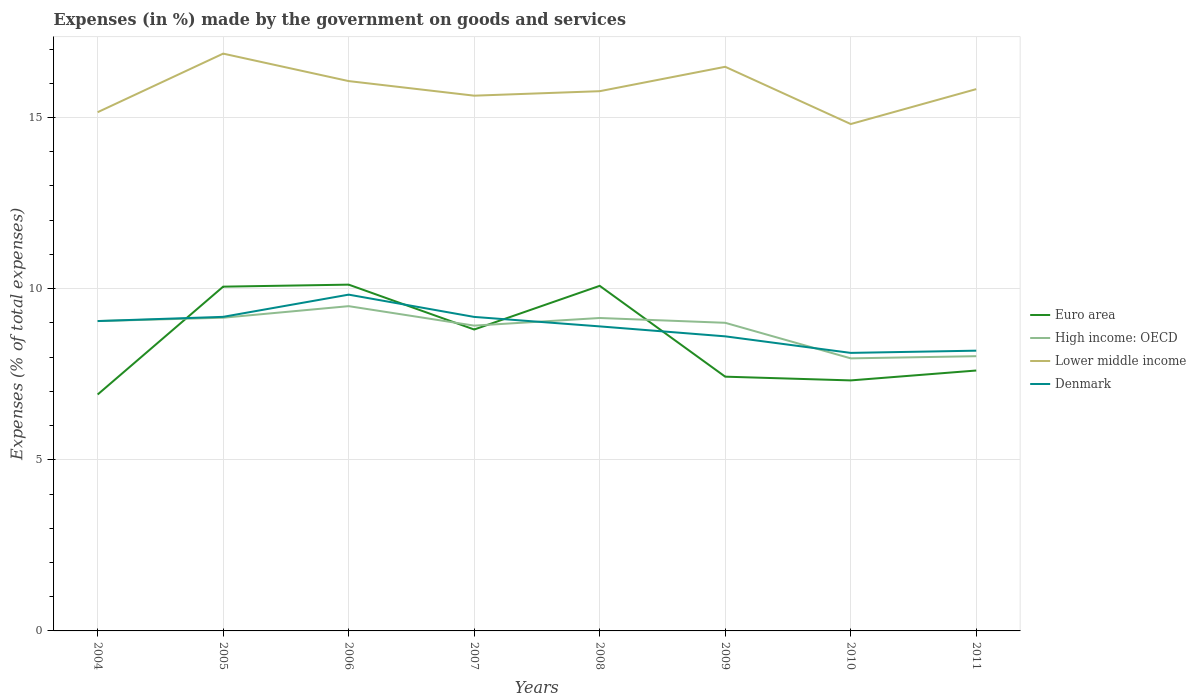Is the number of lines equal to the number of legend labels?
Offer a very short reply. Yes. Across all years, what is the maximum percentage of expenses made by the government on goods and services in High income: OECD?
Give a very brief answer. 7.96. In which year was the percentage of expenses made by the government on goods and services in Denmark maximum?
Ensure brevity in your answer.  2010. What is the total percentage of expenses made by the government on goods and services in Lower middle income in the graph?
Keep it short and to the point. -0.67. What is the difference between the highest and the second highest percentage of expenses made by the government on goods and services in High income: OECD?
Your response must be concise. 1.53. How many lines are there?
Offer a terse response. 4. How many years are there in the graph?
Provide a succinct answer. 8. What is the difference between two consecutive major ticks on the Y-axis?
Ensure brevity in your answer.  5. Are the values on the major ticks of Y-axis written in scientific E-notation?
Keep it short and to the point. No. Does the graph contain any zero values?
Provide a succinct answer. No. How many legend labels are there?
Make the answer very short. 4. What is the title of the graph?
Give a very brief answer. Expenses (in %) made by the government on goods and services. What is the label or title of the Y-axis?
Provide a short and direct response. Expenses (% of total expenses). What is the Expenses (% of total expenses) in Euro area in 2004?
Your response must be concise. 6.91. What is the Expenses (% of total expenses) in High income: OECD in 2004?
Ensure brevity in your answer.  9.05. What is the Expenses (% of total expenses) in Lower middle income in 2004?
Provide a short and direct response. 15.16. What is the Expenses (% of total expenses) of Denmark in 2004?
Provide a short and direct response. 9.05. What is the Expenses (% of total expenses) in Euro area in 2005?
Keep it short and to the point. 10.06. What is the Expenses (% of total expenses) of High income: OECD in 2005?
Make the answer very short. 9.15. What is the Expenses (% of total expenses) in Lower middle income in 2005?
Make the answer very short. 16.87. What is the Expenses (% of total expenses) of Denmark in 2005?
Make the answer very short. 9.18. What is the Expenses (% of total expenses) in Euro area in 2006?
Keep it short and to the point. 10.12. What is the Expenses (% of total expenses) in High income: OECD in 2006?
Provide a succinct answer. 9.49. What is the Expenses (% of total expenses) in Lower middle income in 2006?
Ensure brevity in your answer.  16.07. What is the Expenses (% of total expenses) in Denmark in 2006?
Your answer should be compact. 9.83. What is the Expenses (% of total expenses) in Euro area in 2007?
Give a very brief answer. 8.81. What is the Expenses (% of total expenses) in High income: OECD in 2007?
Keep it short and to the point. 8.92. What is the Expenses (% of total expenses) of Lower middle income in 2007?
Your answer should be very brief. 15.64. What is the Expenses (% of total expenses) in Denmark in 2007?
Offer a very short reply. 9.17. What is the Expenses (% of total expenses) in Euro area in 2008?
Your response must be concise. 10.08. What is the Expenses (% of total expenses) of High income: OECD in 2008?
Offer a terse response. 9.14. What is the Expenses (% of total expenses) in Lower middle income in 2008?
Keep it short and to the point. 15.77. What is the Expenses (% of total expenses) in Denmark in 2008?
Keep it short and to the point. 8.9. What is the Expenses (% of total expenses) of Euro area in 2009?
Offer a terse response. 7.43. What is the Expenses (% of total expenses) in High income: OECD in 2009?
Offer a terse response. 9. What is the Expenses (% of total expenses) in Lower middle income in 2009?
Your response must be concise. 16.48. What is the Expenses (% of total expenses) in Denmark in 2009?
Offer a very short reply. 8.61. What is the Expenses (% of total expenses) of Euro area in 2010?
Provide a short and direct response. 7.32. What is the Expenses (% of total expenses) of High income: OECD in 2010?
Your response must be concise. 7.96. What is the Expenses (% of total expenses) in Lower middle income in 2010?
Offer a very short reply. 14.81. What is the Expenses (% of total expenses) in Denmark in 2010?
Provide a succinct answer. 8.12. What is the Expenses (% of total expenses) in Euro area in 2011?
Provide a short and direct response. 7.61. What is the Expenses (% of total expenses) in High income: OECD in 2011?
Keep it short and to the point. 8.03. What is the Expenses (% of total expenses) of Lower middle income in 2011?
Give a very brief answer. 15.83. What is the Expenses (% of total expenses) in Denmark in 2011?
Provide a succinct answer. 8.19. Across all years, what is the maximum Expenses (% of total expenses) of Euro area?
Ensure brevity in your answer.  10.12. Across all years, what is the maximum Expenses (% of total expenses) in High income: OECD?
Your answer should be compact. 9.49. Across all years, what is the maximum Expenses (% of total expenses) of Lower middle income?
Your answer should be compact. 16.87. Across all years, what is the maximum Expenses (% of total expenses) in Denmark?
Your answer should be compact. 9.83. Across all years, what is the minimum Expenses (% of total expenses) in Euro area?
Ensure brevity in your answer.  6.91. Across all years, what is the minimum Expenses (% of total expenses) in High income: OECD?
Make the answer very short. 7.96. Across all years, what is the minimum Expenses (% of total expenses) of Lower middle income?
Your answer should be compact. 14.81. Across all years, what is the minimum Expenses (% of total expenses) in Denmark?
Keep it short and to the point. 8.12. What is the total Expenses (% of total expenses) of Euro area in the graph?
Keep it short and to the point. 68.33. What is the total Expenses (% of total expenses) in High income: OECD in the graph?
Keep it short and to the point. 70.75. What is the total Expenses (% of total expenses) of Lower middle income in the graph?
Provide a succinct answer. 126.62. What is the total Expenses (% of total expenses) of Denmark in the graph?
Your response must be concise. 71.05. What is the difference between the Expenses (% of total expenses) of Euro area in 2004 and that in 2005?
Provide a succinct answer. -3.15. What is the difference between the Expenses (% of total expenses) of High income: OECD in 2004 and that in 2005?
Your answer should be very brief. -0.1. What is the difference between the Expenses (% of total expenses) in Lower middle income in 2004 and that in 2005?
Ensure brevity in your answer.  -1.71. What is the difference between the Expenses (% of total expenses) of Denmark in 2004 and that in 2005?
Keep it short and to the point. -0.12. What is the difference between the Expenses (% of total expenses) of Euro area in 2004 and that in 2006?
Make the answer very short. -3.21. What is the difference between the Expenses (% of total expenses) of High income: OECD in 2004 and that in 2006?
Provide a succinct answer. -0.44. What is the difference between the Expenses (% of total expenses) of Lower middle income in 2004 and that in 2006?
Your answer should be compact. -0.91. What is the difference between the Expenses (% of total expenses) in Denmark in 2004 and that in 2006?
Your answer should be compact. -0.77. What is the difference between the Expenses (% of total expenses) of Euro area in 2004 and that in 2007?
Your answer should be compact. -1.9. What is the difference between the Expenses (% of total expenses) in High income: OECD in 2004 and that in 2007?
Offer a terse response. 0.13. What is the difference between the Expenses (% of total expenses) of Lower middle income in 2004 and that in 2007?
Provide a succinct answer. -0.48. What is the difference between the Expenses (% of total expenses) of Denmark in 2004 and that in 2007?
Give a very brief answer. -0.12. What is the difference between the Expenses (% of total expenses) of Euro area in 2004 and that in 2008?
Give a very brief answer. -3.18. What is the difference between the Expenses (% of total expenses) of High income: OECD in 2004 and that in 2008?
Keep it short and to the point. -0.09. What is the difference between the Expenses (% of total expenses) of Lower middle income in 2004 and that in 2008?
Offer a terse response. -0.61. What is the difference between the Expenses (% of total expenses) of Denmark in 2004 and that in 2008?
Provide a short and direct response. 0.16. What is the difference between the Expenses (% of total expenses) in Euro area in 2004 and that in 2009?
Offer a terse response. -0.52. What is the difference between the Expenses (% of total expenses) of High income: OECD in 2004 and that in 2009?
Make the answer very short. 0.05. What is the difference between the Expenses (% of total expenses) in Lower middle income in 2004 and that in 2009?
Offer a terse response. -1.33. What is the difference between the Expenses (% of total expenses) of Denmark in 2004 and that in 2009?
Your response must be concise. 0.45. What is the difference between the Expenses (% of total expenses) of Euro area in 2004 and that in 2010?
Offer a terse response. -0.41. What is the difference between the Expenses (% of total expenses) in High income: OECD in 2004 and that in 2010?
Keep it short and to the point. 1.09. What is the difference between the Expenses (% of total expenses) in Lower middle income in 2004 and that in 2010?
Your answer should be compact. 0.35. What is the difference between the Expenses (% of total expenses) in Denmark in 2004 and that in 2010?
Provide a succinct answer. 0.93. What is the difference between the Expenses (% of total expenses) of Euro area in 2004 and that in 2011?
Your answer should be compact. -0.7. What is the difference between the Expenses (% of total expenses) of High income: OECD in 2004 and that in 2011?
Make the answer very short. 1.03. What is the difference between the Expenses (% of total expenses) of Lower middle income in 2004 and that in 2011?
Offer a terse response. -0.67. What is the difference between the Expenses (% of total expenses) in Denmark in 2004 and that in 2011?
Ensure brevity in your answer.  0.87. What is the difference between the Expenses (% of total expenses) of Euro area in 2005 and that in 2006?
Keep it short and to the point. -0.06. What is the difference between the Expenses (% of total expenses) of High income: OECD in 2005 and that in 2006?
Your answer should be compact. -0.34. What is the difference between the Expenses (% of total expenses) of Lower middle income in 2005 and that in 2006?
Your answer should be very brief. 0.8. What is the difference between the Expenses (% of total expenses) of Denmark in 2005 and that in 2006?
Offer a very short reply. -0.65. What is the difference between the Expenses (% of total expenses) in Euro area in 2005 and that in 2007?
Your answer should be compact. 1.25. What is the difference between the Expenses (% of total expenses) of High income: OECD in 2005 and that in 2007?
Give a very brief answer. 0.23. What is the difference between the Expenses (% of total expenses) of Lower middle income in 2005 and that in 2007?
Keep it short and to the point. 1.23. What is the difference between the Expenses (% of total expenses) in Denmark in 2005 and that in 2007?
Keep it short and to the point. 0. What is the difference between the Expenses (% of total expenses) of Euro area in 2005 and that in 2008?
Make the answer very short. -0.02. What is the difference between the Expenses (% of total expenses) in High income: OECD in 2005 and that in 2008?
Provide a succinct answer. 0.01. What is the difference between the Expenses (% of total expenses) of Lower middle income in 2005 and that in 2008?
Make the answer very short. 1.1. What is the difference between the Expenses (% of total expenses) of Denmark in 2005 and that in 2008?
Offer a very short reply. 0.28. What is the difference between the Expenses (% of total expenses) in Euro area in 2005 and that in 2009?
Offer a very short reply. 2.63. What is the difference between the Expenses (% of total expenses) in High income: OECD in 2005 and that in 2009?
Your answer should be compact. 0.15. What is the difference between the Expenses (% of total expenses) in Lower middle income in 2005 and that in 2009?
Your response must be concise. 0.39. What is the difference between the Expenses (% of total expenses) in Denmark in 2005 and that in 2009?
Your response must be concise. 0.57. What is the difference between the Expenses (% of total expenses) of Euro area in 2005 and that in 2010?
Your response must be concise. 2.74. What is the difference between the Expenses (% of total expenses) of High income: OECD in 2005 and that in 2010?
Your answer should be very brief. 1.19. What is the difference between the Expenses (% of total expenses) of Lower middle income in 2005 and that in 2010?
Provide a short and direct response. 2.06. What is the difference between the Expenses (% of total expenses) in Denmark in 2005 and that in 2010?
Ensure brevity in your answer.  1.05. What is the difference between the Expenses (% of total expenses) of Euro area in 2005 and that in 2011?
Your response must be concise. 2.45. What is the difference between the Expenses (% of total expenses) of High income: OECD in 2005 and that in 2011?
Provide a short and direct response. 1.12. What is the difference between the Expenses (% of total expenses) in Lower middle income in 2005 and that in 2011?
Offer a very short reply. 1.04. What is the difference between the Expenses (% of total expenses) of Denmark in 2005 and that in 2011?
Provide a succinct answer. 0.99. What is the difference between the Expenses (% of total expenses) in Euro area in 2006 and that in 2007?
Your answer should be compact. 1.31. What is the difference between the Expenses (% of total expenses) in High income: OECD in 2006 and that in 2007?
Your answer should be compact. 0.57. What is the difference between the Expenses (% of total expenses) of Lower middle income in 2006 and that in 2007?
Keep it short and to the point. 0.43. What is the difference between the Expenses (% of total expenses) in Denmark in 2006 and that in 2007?
Ensure brevity in your answer.  0.65. What is the difference between the Expenses (% of total expenses) of Euro area in 2006 and that in 2008?
Give a very brief answer. 0.04. What is the difference between the Expenses (% of total expenses) in High income: OECD in 2006 and that in 2008?
Offer a terse response. 0.35. What is the difference between the Expenses (% of total expenses) of Lower middle income in 2006 and that in 2008?
Offer a terse response. 0.29. What is the difference between the Expenses (% of total expenses) in Denmark in 2006 and that in 2008?
Give a very brief answer. 0.93. What is the difference between the Expenses (% of total expenses) in Euro area in 2006 and that in 2009?
Keep it short and to the point. 2.69. What is the difference between the Expenses (% of total expenses) in High income: OECD in 2006 and that in 2009?
Offer a terse response. 0.49. What is the difference between the Expenses (% of total expenses) of Lower middle income in 2006 and that in 2009?
Your answer should be very brief. -0.42. What is the difference between the Expenses (% of total expenses) in Denmark in 2006 and that in 2009?
Provide a succinct answer. 1.22. What is the difference between the Expenses (% of total expenses) in Euro area in 2006 and that in 2010?
Ensure brevity in your answer.  2.8. What is the difference between the Expenses (% of total expenses) in High income: OECD in 2006 and that in 2010?
Offer a very short reply. 1.53. What is the difference between the Expenses (% of total expenses) in Lower middle income in 2006 and that in 2010?
Offer a terse response. 1.25. What is the difference between the Expenses (% of total expenses) in Denmark in 2006 and that in 2010?
Give a very brief answer. 1.7. What is the difference between the Expenses (% of total expenses) of Euro area in 2006 and that in 2011?
Your answer should be very brief. 2.51. What is the difference between the Expenses (% of total expenses) in High income: OECD in 2006 and that in 2011?
Offer a very short reply. 1.46. What is the difference between the Expenses (% of total expenses) in Lower middle income in 2006 and that in 2011?
Keep it short and to the point. 0.23. What is the difference between the Expenses (% of total expenses) of Denmark in 2006 and that in 2011?
Provide a succinct answer. 1.64. What is the difference between the Expenses (% of total expenses) in Euro area in 2007 and that in 2008?
Offer a very short reply. -1.28. What is the difference between the Expenses (% of total expenses) in High income: OECD in 2007 and that in 2008?
Provide a succinct answer. -0.22. What is the difference between the Expenses (% of total expenses) of Lower middle income in 2007 and that in 2008?
Your answer should be compact. -0.13. What is the difference between the Expenses (% of total expenses) of Denmark in 2007 and that in 2008?
Provide a succinct answer. 0.28. What is the difference between the Expenses (% of total expenses) of Euro area in 2007 and that in 2009?
Offer a very short reply. 1.38. What is the difference between the Expenses (% of total expenses) of High income: OECD in 2007 and that in 2009?
Your answer should be very brief. -0.08. What is the difference between the Expenses (% of total expenses) in Lower middle income in 2007 and that in 2009?
Your answer should be very brief. -0.84. What is the difference between the Expenses (% of total expenses) in Denmark in 2007 and that in 2009?
Provide a succinct answer. 0.57. What is the difference between the Expenses (% of total expenses) in Euro area in 2007 and that in 2010?
Your answer should be very brief. 1.49. What is the difference between the Expenses (% of total expenses) in High income: OECD in 2007 and that in 2010?
Provide a succinct answer. 0.96. What is the difference between the Expenses (% of total expenses) of Lower middle income in 2007 and that in 2010?
Keep it short and to the point. 0.83. What is the difference between the Expenses (% of total expenses) of Denmark in 2007 and that in 2010?
Your response must be concise. 1.05. What is the difference between the Expenses (% of total expenses) of Euro area in 2007 and that in 2011?
Offer a very short reply. 1.2. What is the difference between the Expenses (% of total expenses) of High income: OECD in 2007 and that in 2011?
Give a very brief answer. 0.89. What is the difference between the Expenses (% of total expenses) in Lower middle income in 2007 and that in 2011?
Your answer should be very brief. -0.19. What is the difference between the Expenses (% of total expenses) in Denmark in 2007 and that in 2011?
Offer a terse response. 0.99. What is the difference between the Expenses (% of total expenses) in Euro area in 2008 and that in 2009?
Offer a terse response. 2.65. What is the difference between the Expenses (% of total expenses) in High income: OECD in 2008 and that in 2009?
Your answer should be very brief. 0.14. What is the difference between the Expenses (% of total expenses) of Lower middle income in 2008 and that in 2009?
Your answer should be compact. -0.71. What is the difference between the Expenses (% of total expenses) of Denmark in 2008 and that in 2009?
Provide a short and direct response. 0.29. What is the difference between the Expenses (% of total expenses) in Euro area in 2008 and that in 2010?
Your answer should be compact. 2.76. What is the difference between the Expenses (% of total expenses) in High income: OECD in 2008 and that in 2010?
Ensure brevity in your answer.  1.18. What is the difference between the Expenses (% of total expenses) in Lower middle income in 2008 and that in 2010?
Make the answer very short. 0.96. What is the difference between the Expenses (% of total expenses) of Denmark in 2008 and that in 2010?
Give a very brief answer. 0.77. What is the difference between the Expenses (% of total expenses) in Euro area in 2008 and that in 2011?
Make the answer very short. 2.47. What is the difference between the Expenses (% of total expenses) of High income: OECD in 2008 and that in 2011?
Give a very brief answer. 1.12. What is the difference between the Expenses (% of total expenses) of Lower middle income in 2008 and that in 2011?
Keep it short and to the point. -0.06. What is the difference between the Expenses (% of total expenses) of Denmark in 2008 and that in 2011?
Provide a short and direct response. 0.71. What is the difference between the Expenses (% of total expenses) of Euro area in 2009 and that in 2010?
Your answer should be very brief. 0.11. What is the difference between the Expenses (% of total expenses) of High income: OECD in 2009 and that in 2010?
Offer a very short reply. 1.04. What is the difference between the Expenses (% of total expenses) of Lower middle income in 2009 and that in 2010?
Offer a very short reply. 1.67. What is the difference between the Expenses (% of total expenses) of Denmark in 2009 and that in 2010?
Make the answer very short. 0.48. What is the difference between the Expenses (% of total expenses) in Euro area in 2009 and that in 2011?
Offer a very short reply. -0.18. What is the difference between the Expenses (% of total expenses) in High income: OECD in 2009 and that in 2011?
Your answer should be very brief. 0.98. What is the difference between the Expenses (% of total expenses) in Lower middle income in 2009 and that in 2011?
Offer a terse response. 0.65. What is the difference between the Expenses (% of total expenses) of Denmark in 2009 and that in 2011?
Your response must be concise. 0.42. What is the difference between the Expenses (% of total expenses) in Euro area in 2010 and that in 2011?
Make the answer very short. -0.29. What is the difference between the Expenses (% of total expenses) in High income: OECD in 2010 and that in 2011?
Keep it short and to the point. -0.06. What is the difference between the Expenses (% of total expenses) of Lower middle income in 2010 and that in 2011?
Offer a very short reply. -1.02. What is the difference between the Expenses (% of total expenses) of Denmark in 2010 and that in 2011?
Offer a very short reply. -0.06. What is the difference between the Expenses (% of total expenses) of Euro area in 2004 and the Expenses (% of total expenses) of High income: OECD in 2005?
Give a very brief answer. -2.24. What is the difference between the Expenses (% of total expenses) of Euro area in 2004 and the Expenses (% of total expenses) of Lower middle income in 2005?
Offer a very short reply. -9.96. What is the difference between the Expenses (% of total expenses) of Euro area in 2004 and the Expenses (% of total expenses) of Denmark in 2005?
Offer a terse response. -2.27. What is the difference between the Expenses (% of total expenses) in High income: OECD in 2004 and the Expenses (% of total expenses) in Lower middle income in 2005?
Your response must be concise. -7.81. What is the difference between the Expenses (% of total expenses) of High income: OECD in 2004 and the Expenses (% of total expenses) of Denmark in 2005?
Provide a succinct answer. -0.12. What is the difference between the Expenses (% of total expenses) of Lower middle income in 2004 and the Expenses (% of total expenses) of Denmark in 2005?
Provide a short and direct response. 5.98. What is the difference between the Expenses (% of total expenses) of Euro area in 2004 and the Expenses (% of total expenses) of High income: OECD in 2006?
Provide a succinct answer. -2.58. What is the difference between the Expenses (% of total expenses) of Euro area in 2004 and the Expenses (% of total expenses) of Lower middle income in 2006?
Give a very brief answer. -9.16. What is the difference between the Expenses (% of total expenses) in Euro area in 2004 and the Expenses (% of total expenses) in Denmark in 2006?
Your answer should be compact. -2.92. What is the difference between the Expenses (% of total expenses) of High income: OECD in 2004 and the Expenses (% of total expenses) of Lower middle income in 2006?
Ensure brevity in your answer.  -7.01. What is the difference between the Expenses (% of total expenses) of High income: OECD in 2004 and the Expenses (% of total expenses) of Denmark in 2006?
Provide a short and direct response. -0.77. What is the difference between the Expenses (% of total expenses) in Lower middle income in 2004 and the Expenses (% of total expenses) in Denmark in 2006?
Provide a succinct answer. 5.33. What is the difference between the Expenses (% of total expenses) of Euro area in 2004 and the Expenses (% of total expenses) of High income: OECD in 2007?
Your answer should be compact. -2.01. What is the difference between the Expenses (% of total expenses) in Euro area in 2004 and the Expenses (% of total expenses) in Lower middle income in 2007?
Keep it short and to the point. -8.73. What is the difference between the Expenses (% of total expenses) of Euro area in 2004 and the Expenses (% of total expenses) of Denmark in 2007?
Keep it short and to the point. -2.27. What is the difference between the Expenses (% of total expenses) in High income: OECD in 2004 and the Expenses (% of total expenses) in Lower middle income in 2007?
Offer a very short reply. -6.59. What is the difference between the Expenses (% of total expenses) of High income: OECD in 2004 and the Expenses (% of total expenses) of Denmark in 2007?
Your answer should be very brief. -0.12. What is the difference between the Expenses (% of total expenses) of Lower middle income in 2004 and the Expenses (% of total expenses) of Denmark in 2007?
Your answer should be compact. 5.98. What is the difference between the Expenses (% of total expenses) of Euro area in 2004 and the Expenses (% of total expenses) of High income: OECD in 2008?
Your answer should be compact. -2.24. What is the difference between the Expenses (% of total expenses) in Euro area in 2004 and the Expenses (% of total expenses) in Lower middle income in 2008?
Give a very brief answer. -8.86. What is the difference between the Expenses (% of total expenses) of Euro area in 2004 and the Expenses (% of total expenses) of Denmark in 2008?
Offer a very short reply. -1.99. What is the difference between the Expenses (% of total expenses) in High income: OECD in 2004 and the Expenses (% of total expenses) in Lower middle income in 2008?
Your response must be concise. -6.72. What is the difference between the Expenses (% of total expenses) of High income: OECD in 2004 and the Expenses (% of total expenses) of Denmark in 2008?
Offer a terse response. 0.16. What is the difference between the Expenses (% of total expenses) in Lower middle income in 2004 and the Expenses (% of total expenses) in Denmark in 2008?
Make the answer very short. 6.26. What is the difference between the Expenses (% of total expenses) in Euro area in 2004 and the Expenses (% of total expenses) in High income: OECD in 2009?
Your answer should be compact. -2.1. What is the difference between the Expenses (% of total expenses) of Euro area in 2004 and the Expenses (% of total expenses) of Lower middle income in 2009?
Offer a terse response. -9.58. What is the difference between the Expenses (% of total expenses) of Euro area in 2004 and the Expenses (% of total expenses) of Denmark in 2009?
Provide a succinct answer. -1.7. What is the difference between the Expenses (% of total expenses) in High income: OECD in 2004 and the Expenses (% of total expenses) in Lower middle income in 2009?
Your response must be concise. -7.43. What is the difference between the Expenses (% of total expenses) in High income: OECD in 2004 and the Expenses (% of total expenses) in Denmark in 2009?
Make the answer very short. 0.45. What is the difference between the Expenses (% of total expenses) in Lower middle income in 2004 and the Expenses (% of total expenses) in Denmark in 2009?
Make the answer very short. 6.55. What is the difference between the Expenses (% of total expenses) in Euro area in 2004 and the Expenses (% of total expenses) in High income: OECD in 2010?
Offer a very short reply. -1.06. What is the difference between the Expenses (% of total expenses) in Euro area in 2004 and the Expenses (% of total expenses) in Lower middle income in 2010?
Provide a succinct answer. -7.9. What is the difference between the Expenses (% of total expenses) in Euro area in 2004 and the Expenses (% of total expenses) in Denmark in 2010?
Provide a short and direct response. -1.22. What is the difference between the Expenses (% of total expenses) of High income: OECD in 2004 and the Expenses (% of total expenses) of Lower middle income in 2010?
Keep it short and to the point. -5.76. What is the difference between the Expenses (% of total expenses) of High income: OECD in 2004 and the Expenses (% of total expenses) of Denmark in 2010?
Provide a short and direct response. 0.93. What is the difference between the Expenses (% of total expenses) in Lower middle income in 2004 and the Expenses (% of total expenses) in Denmark in 2010?
Provide a short and direct response. 7.03. What is the difference between the Expenses (% of total expenses) of Euro area in 2004 and the Expenses (% of total expenses) of High income: OECD in 2011?
Give a very brief answer. -1.12. What is the difference between the Expenses (% of total expenses) in Euro area in 2004 and the Expenses (% of total expenses) in Lower middle income in 2011?
Keep it short and to the point. -8.92. What is the difference between the Expenses (% of total expenses) of Euro area in 2004 and the Expenses (% of total expenses) of Denmark in 2011?
Your answer should be very brief. -1.28. What is the difference between the Expenses (% of total expenses) of High income: OECD in 2004 and the Expenses (% of total expenses) of Lower middle income in 2011?
Your answer should be compact. -6.78. What is the difference between the Expenses (% of total expenses) in High income: OECD in 2004 and the Expenses (% of total expenses) in Denmark in 2011?
Make the answer very short. 0.87. What is the difference between the Expenses (% of total expenses) of Lower middle income in 2004 and the Expenses (% of total expenses) of Denmark in 2011?
Give a very brief answer. 6.97. What is the difference between the Expenses (% of total expenses) of Euro area in 2005 and the Expenses (% of total expenses) of High income: OECD in 2006?
Keep it short and to the point. 0.57. What is the difference between the Expenses (% of total expenses) of Euro area in 2005 and the Expenses (% of total expenses) of Lower middle income in 2006?
Ensure brevity in your answer.  -6.01. What is the difference between the Expenses (% of total expenses) of Euro area in 2005 and the Expenses (% of total expenses) of Denmark in 2006?
Provide a short and direct response. 0.23. What is the difference between the Expenses (% of total expenses) in High income: OECD in 2005 and the Expenses (% of total expenses) in Lower middle income in 2006?
Make the answer very short. -6.91. What is the difference between the Expenses (% of total expenses) of High income: OECD in 2005 and the Expenses (% of total expenses) of Denmark in 2006?
Offer a very short reply. -0.67. What is the difference between the Expenses (% of total expenses) of Lower middle income in 2005 and the Expenses (% of total expenses) of Denmark in 2006?
Give a very brief answer. 7.04. What is the difference between the Expenses (% of total expenses) of Euro area in 2005 and the Expenses (% of total expenses) of High income: OECD in 2007?
Make the answer very short. 1.14. What is the difference between the Expenses (% of total expenses) in Euro area in 2005 and the Expenses (% of total expenses) in Lower middle income in 2007?
Give a very brief answer. -5.58. What is the difference between the Expenses (% of total expenses) in Euro area in 2005 and the Expenses (% of total expenses) in Denmark in 2007?
Your response must be concise. 0.88. What is the difference between the Expenses (% of total expenses) in High income: OECD in 2005 and the Expenses (% of total expenses) in Lower middle income in 2007?
Your answer should be very brief. -6.49. What is the difference between the Expenses (% of total expenses) in High income: OECD in 2005 and the Expenses (% of total expenses) in Denmark in 2007?
Keep it short and to the point. -0.02. What is the difference between the Expenses (% of total expenses) of Lower middle income in 2005 and the Expenses (% of total expenses) of Denmark in 2007?
Ensure brevity in your answer.  7.69. What is the difference between the Expenses (% of total expenses) in Euro area in 2005 and the Expenses (% of total expenses) in High income: OECD in 2008?
Ensure brevity in your answer.  0.92. What is the difference between the Expenses (% of total expenses) of Euro area in 2005 and the Expenses (% of total expenses) of Lower middle income in 2008?
Ensure brevity in your answer.  -5.71. What is the difference between the Expenses (% of total expenses) in Euro area in 2005 and the Expenses (% of total expenses) in Denmark in 2008?
Give a very brief answer. 1.16. What is the difference between the Expenses (% of total expenses) in High income: OECD in 2005 and the Expenses (% of total expenses) in Lower middle income in 2008?
Ensure brevity in your answer.  -6.62. What is the difference between the Expenses (% of total expenses) in High income: OECD in 2005 and the Expenses (% of total expenses) in Denmark in 2008?
Give a very brief answer. 0.25. What is the difference between the Expenses (% of total expenses) in Lower middle income in 2005 and the Expenses (% of total expenses) in Denmark in 2008?
Make the answer very short. 7.97. What is the difference between the Expenses (% of total expenses) in Euro area in 2005 and the Expenses (% of total expenses) in High income: OECD in 2009?
Give a very brief answer. 1.06. What is the difference between the Expenses (% of total expenses) in Euro area in 2005 and the Expenses (% of total expenses) in Lower middle income in 2009?
Give a very brief answer. -6.42. What is the difference between the Expenses (% of total expenses) of Euro area in 2005 and the Expenses (% of total expenses) of Denmark in 2009?
Your answer should be compact. 1.45. What is the difference between the Expenses (% of total expenses) of High income: OECD in 2005 and the Expenses (% of total expenses) of Lower middle income in 2009?
Offer a very short reply. -7.33. What is the difference between the Expenses (% of total expenses) of High income: OECD in 2005 and the Expenses (% of total expenses) of Denmark in 2009?
Your response must be concise. 0.54. What is the difference between the Expenses (% of total expenses) in Lower middle income in 2005 and the Expenses (% of total expenses) in Denmark in 2009?
Ensure brevity in your answer.  8.26. What is the difference between the Expenses (% of total expenses) of Euro area in 2005 and the Expenses (% of total expenses) of High income: OECD in 2010?
Ensure brevity in your answer.  2.09. What is the difference between the Expenses (% of total expenses) of Euro area in 2005 and the Expenses (% of total expenses) of Lower middle income in 2010?
Offer a terse response. -4.75. What is the difference between the Expenses (% of total expenses) of Euro area in 2005 and the Expenses (% of total expenses) of Denmark in 2010?
Offer a very short reply. 1.94. What is the difference between the Expenses (% of total expenses) of High income: OECD in 2005 and the Expenses (% of total expenses) of Lower middle income in 2010?
Make the answer very short. -5.66. What is the difference between the Expenses (% of total expenses) of High income: OECD in 2005 and the Expenses (% of total expenses) of Denmark in 2010?
Keep it short and to the point. 1.03. What is the difference between the Expenses (% of total expenses) of Lower middle income in 2005 and the Expenses (% of total expenses) of Denmark in 2010?
Your response must be concise. 8.74. What is the difference between the Expenses (% of total expenses) in Euro area in 2005 and the Expenses (% of total expenses) in High income: OECD in 2011?
Ensure brevity in your answer.  2.03. What is the difference between the Expenses (% of total expenses) in Euro area in 2005 and the Expenses (% of total expenses) in Lower middle income in 2011?
Offer a terse response. -5.77. What is the difference between the Expenses (% of total expenses) of Euro area in 2005 and the Expenses (% of total expenses) of Denmark in 2011?
Make the answer very short. 1.87. What is the difference between the Expenses (% of total expenses) of High income: OECD in 2005 and the Expenses (% of total expenses) of Lower middle income in 2011?
Your response must be concise. -6.68. What is the difference between the Expenses (% of total expenses) in High income: OECD in 2005 and the Expenses (% of total expenses) in Denmark in 2011?
Give a very brief answer. 0.96. What is the difference between the Expenses (% of total expenses) of Lower middle income in 2005 and the Expenses (% of total expenses) of Denmark in 2011?
Offer a very short reply. 8.68. What is the difference between the Expenses (% of total expenses) of Euro area in 2006 and the Expenses (% of total expenses) of High income: OECD in 2007?
Make the answer very short. 1.2. What is the difference between the Expenses (% of total expenses) of Euro area in 2006 and the Expenses (% of total expenses) of Lower middle income in 2007?
Give a very brief answer. -5.52. What is the difference between the Expenses (% of total expenses) of Euro area in 2006 and the Expenses (% of total expenses) of Denmark in 2007?
Make the answer very short. 0.94. What is the difference between the Expenses (% of total expenses) of High income: OECD in 2006 and the Expenses (% of total expenses) of Lower middle income in 2007?
Offer a very short reply. -6.15. What is the difference between the Expenses (% of total expenses) of High income: OECD in 2006 and the Expenses (% of total expenses) of Denmark in 2007?
Provide a succinct answer. 0.31. What is the difference between the Expenses (% of total expenses) in Lower middle income in 2006 and the Expenses (% of total expenses) in Denmark in 2007?
Ensure brevity in your answer.  6.89. What is the difference between the Expenses (% of total expenses) in Euro area in 2006 and the Expenses (% of total expenses) in High income: OECD in 2008?
Ensure brevity in your answer.  0.97. What is the difference between the Expenses (% of total expenses) of Euro area in 2006 and the Expenses (% of total expenses) of Lower middle income in 2008?
Make the answer very short. -5.65. What is the difference between the Expenses (% of total expenses) of Euro area in 2006 and the Expenses (% of total expenses) of Denmark in 2008?
Offer a terse response. 1.22. What is the difference between the Expenses (% of total expenses) of High income: OECD in 2006 and the Expenses (% of total expenses) of Lower middle income in 2008?
Keep it short and to the point. -6.28. What is the difference between the Expenses (% of total expenses) in High income: OECD in 2006 and the Expenses (% of total expenses) in Denmark in 2008?
Provide a short and direct response. 0.59. What is the difference between the Expenses (% of total expenses) in Lower middle income in 2006 and the Expenses (% of total expenses) in Denmark in 2008?
Provide a succinct answer. 7.17. What is the difference between the Expenses (% of total expenses) in Euro area in 2006 and the Expenses (% of total expenses) in High income: OECD in 2009?
Provide a short and direct response. 1.12. What is the difference between the Expenses (% of total expenses) of Euro area in 2006 and the Expenses (% of total expenses) of Lower middle income in 2009?
Your answer should be compact. -6.36. What is the difference between the Expenses (% of total expenses) of Euro area in 2006 and the Expenses (% of total expenses) of Denmark in 2009?
Keep it short and to the point. 1.51. What is the difference between the Expenses (% of total expenses) in High income: OECD in 2006 and the Expenses (% of total expenses) in Lower middle income in 2009?
Your response must be concise. -6.99. What is the difference between the Expenses (% of total expenses) of High income: OECD in 2006 and the Expenses (% of total expenses) of Denmark in 2009?
Provide a succinct answer. 0.88. What is the difference between the Expenses (% of total expenses) of Lower middle income in 2006 and the Expenses (% of total expenses) of Denmark in 2009?
Provide a short and direct response. 7.46. What is the difference between the Expenses (% of total expenses) in Euro area in 2006 and the Expenses (% of total expenses) in High income: OECD in 2010?
Your answer should be very brief. 2.15. What is the difference between the Expenses (% of total expenses) of Euro area in 2006 and the Expenses (% of total expenses) of Lower middle income in 2010?
Provide a short and direct response. -4.69. What is the difference between the Expenses (% of total expenses) in Euro area in 2006 and the Expenses (% of total expenses) in Denmark in 2010?
Your response must be concise. 1.99. What is the difference between the Expenses (% of total expenses) of High income: OECD in 2006 and the Expenses (% of total expenses) of Lower middle income in 2010?
Offer a terse response. -5.32. What is the difference between the Expenses (% of total expenses) in High income: OECD in 2006 and the Expenses (% of total expenses) in Denmark in 2010?
Offer a terse response. 1.37. What is the difference between the Expenses (% of total expenses) in Lower middle income in 2006 and the Expenses (% of total expenses) in Denmark in 2010?
Ensure brevity in your answer.  7.94. What is the difference between the Expenses (% of total expenses) in Euro area in 2006 and the Expenses (% of total expenses) in High income: OECD in 2011?
Make the answer very short. 2.09. What is the difference between the Expenses (% of total expenses) of Euro area in 2006 and the Expenses (% of total expenses) of Lower middle income in 2011?
Provide a succinct answer. -5.71. What is the difference between the Expenses (% of total expenses) in Euro area in 2006 and the Expenses (% of total expenses) in Denmark in 2011?
Provide a succinct answer. 1.93. What is the difference between the Expenses (% of total expenses) in High income: OECD in 2006 and the Expenses (% of total expenses) in Lower middle income in 2011?
Provide a succinct answer. -6.34. What is the difference between the Expenses (% of total expenses) in High income: OECD in 2006 and the Expenses (% of total expenses) in Denmark in 2011?
Keep it short and to the point. 1.3. What is the difference between the Expenses (% of total expenses) of Lower middle income in 2006 and the Expenses (% of total expenses) of Denmark in 2011?
Give a very brief answer. 7.88. What is the difference between the Expenses (% of total expenses) in Euro area in 2007 and the Expenses (% of total expenses) in High income: OECD in 2008?
Provide a short and direct response. -0.34. What is the difference between the Expenses (% of total expenses) in Euro area in 2007 and the Expenses (% of total expenses) in Lower middle income in 2008?
Make the answer very short. -6.96. What is the difference between the Expenses (% of total expenses) of Euro area in 2007 and the Expenses (% of total expenses) of Denmark in 2008?
Ensure brevity in your answer.  -0.09. What is the difference between the Expenses (% of total expenses) of High income: OECD in 2007 and the Expenses (% of total expenses) of Lower middle income in 2008?
Offer a terse response. -6.85. What is the difference between the Expenses (% of total expenses) of High income: OECD in 2007 and the Expenses (% of total expenses) of Denmark in 2008?
Ensure brevity in your answer.  0.02. What is the difference between the Expenses (% of total expenses) in Lower middle income in 2007 and the Expenses (% of total expenses) in Denmark in 2008?
Your answer should be compact. 6.74. What is the difference between the Expenses (% of total expenses) in Euro area in 2007 and the Expenses (% of total expenses) in High income: OECD in 2009?
Make the answer very short. -0.2. What is the difference between the Expenses (% of total expenses) in Euro area in 2007 and the Expenses (% of total expenses) in Lower middle income in 2009?
Offer a terse response. -7.68. What is the difference between the Expenses (% of total expenses) in Euro area in 2007 and the Expenses (% of total expenses) in Denmark in 2009?
Your answer should be compact. 0.2. What is the difference between the Expenses (% of total expenses) in High income: OECD in 2007 and the Expenses (% of total expenses) in Lower middle income in 2009?
Provide a short and direct response. -7.56. What is the difference between the Expenses (% of total expenses) in High income: OECD in 2007 and the Expenses (% of total expenses) in Denmark in 2009?
Ensure brevity in your answer.  0.31. What is the difference between the Expenses (% of total expenses) in Lower middle income in 2007 and the Expenses (% of total expenses) in Denmark in 2009?
Your answer should be very brief. 7.03. What is the difference between the Expenses (% of total expenses) of Euro area in 2007 and the Expenses (% of total expenses) of High income: OECD in 2010?
Your response must be concise. 0.84. What is the difference between the Expenses (% of total expenses) in Euro area in 2007 and the Expenses (% of total expenses) in Lower middle income in 2010?
Your response must be concise. -6. What is the difference between the Expenses (% of total expenses) in Euro area in 2007 and the Expenses (% of total expenses) in Denmark in 2010?
Provide a short and direct response. 0.68. What is the difference between the Expenses (% of total expenses) in High income: OECD in 2007 and the Expenses (% of total expenses) in Lower middle income in 2010?
Offer a terse response. -5.89. What is the difference between the Expenses (% of total expenses) in High income: OECD in 2007 and the Expenses (% of total expenses) in Denmark in 2010?
Provide a succinct answer. 0.8. What is the difference between the Expenses (% of total expenses) of Lower middle income in 2007 and the Expenses (% of total expenses) of Denmark in 2010?
Your answer should be compact. 7.52. What is the difference between the Expenses (% of total expenses) in Euro area in 2007 and the Expenses (% of total expenses) in High income: OECD in 2011?
Your answer should be compact. 0.78. What is the difference between the Expenses (% of total expenses) of Euro area in 2007 and the Expenses (% of total expenses) of Lower middle income in 2011?
Ensure brevity in your answer.  -7.02. What is the difference between the Expenses (% of total expenses) of Euro area in 2007 and the Expenses (% of total expenses) of Denmark in 2011?
Provide a succinct answer. 0.62. What is the difference between the Expenses (% of total expenses) in High income: OECD in 2007 and the Expenses (% of total expenses) in Lower middle income in 2011?
Offer a very short reply. -6.91. What is the difference between the Expenses (% of total expenses) of High income: OECD in 2007 and the Expenses (% of total expenses) of Denmark in 2011?
Offer a very short reply. 0.73. What is the difference between the Expenses (% of total expenses) in Lower middle income in 2007 and the Expenses (% of total expenses) in Denmark in 2011?
Provide a short and direct response. 7.45. What is the difference between the Expenses (% of total expenses) in Euro area in 2008 and the Expenses (% of total expenses) in High income: OECD in 2009?
Your response must be concise. 1.08. What is the difference between the Expenses (% of total expenses) in Euro area in 2008 and the Expenses (% of total expenses) in Lower middle income in 2009?
Give a very brief answer. -6.4. What is the difference between the Expenses (% of total expenses) of Euro area in 2008 and the Expenses (% of total expenses) of Denmark in 2009?
Ensure brevity in your answer.  1.48. What is the difference between the Expenses (% of total expenses) in High income: OECD in 2008 and the Expenses (% of total expenses) in Lower middle income in 2009?
Your answer should be compact. -7.34. What is the difference between the Expenses (% of total expenses) of High income: OECD in 2008 and the Expenses (% of total expenses) of Denmark in 2009?
Provide a succinct answer. 0.54. What is the difference between the Expenses (% of total expenses) in Lower middle income in 2008 and the Expenses (% of total expenses) in Denmark in 2009?
Ensure brevity in your answer.  7.16. What is the difference between the Expenses (% of total expenses) in Euro area in 2008 and the Expenses (% of total expenses) in High income: OECD in 2010?
Offer a terse response. 2.12. What is the difference between the Expenses (% of total expenses) of Euro area in 2008 and the Expenses (% of total expenses) of Lower middle income in 2010?
Provide a succinct answer. -4.73. What is the difference between the Expenses (% of total expenses) of Euro area in 2008 and the Expenses (% of total expenses) of Denmark in 2010?
Your answer should be compact. 1.96. What is the difference between the Expenses (% of total expenses) in High income: OECD in 2008 and the Expenses (% of total expenses) in Lower middle income in 2010?
Provide a short and direct response. -5.67. What is the difference between the Expenses (% of total expenses) of High income: OECD in 2008 and the Expenses (% of total expenses) of Denmark in 2010?
Provide a succinct answer. 1.02. What is the difference between the Expenses (% of total expenses) of Lower middle income in 2008 and the Expenses (% of total expenses) of Denmark in 2010?
Offer a terse response. 7.65. What is the difference between the Expenses (% of total expenses) in Euro area in 2008 and the Expenses (% of total expenses) in High income: OECD in 2011?
Ensure brevity in your answer.  2.06. What is the difference between the Expenses (% of total expenses) of Euro area in 2008 and the Expenses (% of total expenses) of Lower middle income in 2011?
Ensure brevity in your answer.  -5.75. What is the difference between the Expenses (% of total expenses) of Euro area in 2008 and the Expenses (% of total expenses) of Denmark in 2011?
Make the answer very short. 1.89. What is the difference between the Expenses (% of total expenses) of High income: OECD in 2008 and the Expenses (% of total expenses) of Lower middle income in 2011?
Provide a short and direct response. -6.69. What is the difference between the Expenses (% of total expenses) of High income: OECD in 2008 and the Expenses (% of total expenses) of Denmark in 2011?
Make the answer very short. 0.95. What is the difference between the Expenses (% of total expenses) of Lower middle income in 2008 and the Expenses (% of total expenses) of Denmark in 2011?
Your answer should be compact. 7.58. What is the difference between the Expenses (% of total expenses) of Euro area in 2009 and the Expenses (% of total expenses) of High income: OECD in 2010?
Your response must be concise. -0.54. What is the difference between the Expenses (% of total expenses) in Euro area in 2009 and the Expenses (% of total expenses) in Lower middle income in 2010?
Offer a terse response. -7.38. What is the difference between the Expenses (% of total expenses) of Euro area in 2009 and the Expenses (% of total expenses) of Denmark in 2010?
Offer a terse response. -0.69. What is the difference between the Expenses (% of total expenses) in High income: OECD in 2009 and the Expenses (% of total expenses) in Lower middle income in 2010?
Your response must be concise. -5.81. What is the difference between the Expenses (% of total expenses) of High income: OECD in 2009 and the Expenses (% of total expenses) of Denmark in 2010?
Keep it short and to the point. 0.88. What is the difference between the Expenses (% of total expenses) of Lower middle income in 2009 and the Expenses (% of total expenses) of Denmark in 2010?
Keep it short and to the point. 8.36. What is the difference between the Expenses (% of total expenses) of Euro area in 2009 and the Expenses (% of total expenses) of High income: OECD in 2011?
Make the answer very short. -0.6. What is the difference between the Expenses (% of total expenses) of Euro area in 2009 and the Expenses (% of total expenses) of Lower middle income in 2011?
Keep it short and to the point. -8.4. What is the difference between the Expenses (% of total expenses) in Euro area in 2009 and the Expenses (% of total expenses) in Denmark in 2011?
Keep it short and to the point. -0.76. What is the difference between the Expenses (% of total expenses) of High income: OECD in 2009 and the Expenses (% of total expenses) of Lower middle income in 2011?
Your response must be concise. -6.83. What is the difference between the Expenses (% of total expenses) of High income: OECD in 2009 and the Expenses (% of total expenses) of Denmark in 2011?
Provide a short and direct response. 0.81. What is the difference between the Expenses (% of total expenses) in Lower middle income in 2009 and the Expenses (% of total expenses) in Denmark in 2011?
Ensure brevity in your answer.  8.29. What is the difference between the Expenses (% of total expenses) in Euro area in 2010 and the Expenses (% of total expenses) in High income: OECD in 2011?
Ensure brevity in your answer.  -0.71. What is the difference between the Expenses (% of total expenses) in Euro area in 2010 and the Expenses (% of total expenses) in Lower middle income in 2011?
Keep it short and to the point. -8.51. What is the difference between the Expenses (% of total expenses) in Euro area in 2010 and the Expenses (% of total expenses) in Denmark in 2011?
Your answer should be compact. -0.87. What is the difference between the Expenses (% of total expenses) in High income: OECD in 2010 and the Expenses (% of total expenses) in Lower middle income in 2011?
Offer a terse response. -7.87. What is the difference between the Expenses (% of total expenses) of High income: OECD in 2010 and the Expenses (% of total expenses) of Denmark in 2011?
Make the answer very short. -0.22. What is the difference between the Expenses (% of total expenses) of Lower middle income in 2010 and the Expenses (% of total expenses) of Denmark in 2011?
Keep it short and to the point. 6.62. What is the average Expenses (% of total expenses) in Euro area per year?
Give a very brief answer. 8.54. What is the average Expenses (% of total expenses) in High income: OECD per year?
Your response must be concise. 8.84. What is the average Expenses (% of total expenses) in Lower middle income per year?
Offer a very short reply. 15.83. What is the average Expenses (% of total expenses) in Denmark per year?
Give a very brief answer. 8.88. In the year 2004, what is the difference between the Expenses (% of total expenses) in Euro area and Expenses (% of total expenses) in High income: OECD?
Your answer should be very brief. -2.15. In the year 2004, what is the difference between the Expenses (% of total expenses) in Euro area and Expenses (% of total expenses) in Lower middle income?
Provide a succinct answer. -8.25. In the year 2004, what is the difference between the Expenses (% of total expenses) of Euro area and Expenses (% of total expenses) of Denmark?
Offer a very short reply. -2.15. In the year 2004, what is the difference between the Expenses (% of total expenses) of High income: OECD and Expenses (% of total expenses) of Lower middle income?
Make the answer very short. -6.1. In the year 2004, what is the difference between the Expenses (% of total expenses) in Lower middle income and Expenses (% of total expenses) in Denmark?
Offer a terse response. 6.1. In the year 2005, what is the difference between the Expenses (% of total expenses) of Euro area and Expenses (% of total expenses) of High income: OECD?
Your answer should be compact. 0.91. In the year 2005, what is the difference between the Expenses (% of total expenses) in Euro area and Expenses (% of total expenses) in Lower middle income?
Offer a very short reply. -6.81. In the year 2005, what is the difference between the Expenses (% of total expenses) in Euro area and Expenses (% of total expenses) in Denmark?
Your answer should be compact. 0.88. In the year 2005, what is the difference between the Expenses (% of total expenses) in High income: OECD and Expenses (% of total expenses) in Lower middle income?
Your answer should be very brief. -7.72. In the year 2005, what is the difference between the Expenses (% of total expenses) of High income: OECD and Expenses (% of total expenses) of Denmark?
Keep it short and to the point. -0.03. In the year 2005, what is the difference between the Expenses (% of total expenses) of Lower middle income and Expenses (% of total expenses) of Denmark?
Keep it short and to the point. 7.69. In the year 2006, what is the difference between the Expenses (% of total expenses) of Euro area and Expenses (% of total expenses) of High income: OECD?
Provide a short and direct response. 0.63. In the year 2006, what is the difference between the Expenses (% of total expenses) of Euro area and Expenses (% of total expenses) of Lower middle income?
Provide a succinct answer. -5.95. In the year 2006, what is the difference between the Expenses (% of total expenses) of Euro area and Expenses (% of total expenses) of Denmark?
Make the answer very short. 0.29. In the year 2006, what is the difference between the Expenses (% of total expenses) in High income: OECD and Expenses (% of total expenses) in Lower middle income?
Your answer should be compact. -6.58. In the year 2006, what is the difference between the Expenses (% of total expenses) in High income: OECD and Expenses (% of total expenses) in Denmark?
Give a very brief answer. -0.34. In the year 2006, what is the difference between the Expenses (% of total expenses) in Lower middle income and Expenses (% of total expenses) in Denmark?
Your answer should be compact. 6.24. In the year 2007, what is the difference between the Expenses (% of total expenses) in Euro area and Expenses (% of total expenses) in High income: OECD?
Keep it short and to the point. -0.11. In the year 2007, what is the difference between the Expenses (% of total expenses) in Euro area and Expenses (% of total expenses) in Lower middle income?
Provide a short and direct response. -6.83. In the year 2007, what is the difference between the Expenses (% of total expenses) of Euro area and Expenses (% of total expenses) of Denmark?
Make the answer very short. -0.37. In the year 2007, what is the difference between the Expenses (% of total expenses) of High income: OECD and Expenses (% of total expenses) of Lower middle income?
Provide a short and direct response. -6.72. In the year 2007, what is the difference between the Expenses (% of total expenses) in High income: OECD and Expenses (% of total expenses) in Denmark?
Your answer should be very brief. -0.25. In the year 2007, what is the difference between the Expenses (% of total expenses) in Lower middle income and Expenses (% of total expenses) in Denmark?
Your response must be concise. 6.46. In the year 2008, what is the difference between the Expenses (% of total expenses) in Euro area and Expenses (% of total expenses) in High income: OECD?
Provide a short and direct response. 0.94. In the year 2008, what is the difference between the Expenses (% of total expenses) of Euro area and Expenses (% of total expenses) of Lower middle income?
Provide a succinct answer. -5.69. In the year 2008, what is the difference between the Expenses (% of total expenses) in Euro area and Expenses (% of total expenses) in Denmark?
Offer a terse response. 1.19. In the year 2008, what is the difference between the Expenses (% of total expenses) of High income: OECD and Expenses (% of total expenses) of Lower middle income?
Keep it short and to the point. -6.63. In the year 2008, what is the difference between the Expenses (% of total expenses) of High income: OECD and Expenses (% of total expenses) of Denmark?
Make the answer very short. 0.25. In the year 2008, what is the difference between the Expenses (% of total expenses) of Lower middle income and Expenses (% of total expenses) of Denmark?
Provide a succinct answer. 6.87. In the year 2009, what is the difference between the Expenses (% of total expenses) in Euro area and Expenses (% of total expenses) in High income: OECD?
Ensure brevity in your answer.  -1.57. In the year 2009, what is the difference between the Expenses (% of total expenses) in Euro area and Expenses (% of total expenses) in Lower middle income?
Your response must be concise. -9.05. In the year 2009, what is the difference between the Expenses (% of total expenses) in Euro area and Expenses (% of total expenses) in Denmark?
Provide a succinct answer. -1.18. In the year 2009, what is the difference between the Expenses (% of total expenses) in High income: OECD and Expenses (% of total expenses) in Lower middle income?
Provide a short and direct response. -7.48. In the year 2009, what is the difference between the Expenses (% of total expenses) in High income: OECD and Expenses (% of total expenses) in Denmark?
Keep it short and to the point. 0.4. In the year 2009, what is the difference between the Expenses (% of total expenses) in Lower middle income and Expenses (% of total expenses) in Denmark?
Give a very brief answer. 7.88. In the year 2010, what is the difference between the Expenses (% of total expenses) of Euro area and Expenses (% of total expenses) of High income: OECD?
Provide a succinct answer. -0.64. In the year 2010, what is the difference between the Expenses (% of total expenses) in Euro area and Expenses (% of total expenses) in Lower middle income?
Offer a terse response. -7.49. In the year 2010, what is the difference between the Expenses (% of total expenses) in Euro area and Expenses (% of total expenses) in Denmark?
Your answer should be compact. -0.8. In the year 2010, what is the difference between the Expenses (% of total expenses) of High income: OECD and Expenses (% of total expenses) of Lower middle income?
Give a very brief answer. -6.85. In the year 2010, what is the difference between the Expenses (% of total expenses) in High income: OECD and Expenses (% of total expenses) in Denmark?
Keep it short and to the point. -0.16. In the year 2010, what is the difference between the Expenses (% of total expenses) of Lower middle income and Expenses (% of total expenses) of Denmark?
Offer a very short reply. 6.69. In the year 2011, what is the difference between the Expenses (% of total expenses) in Euro area and Expenses (% of total expenses) in High income: OECD?
Offer a very short reply. -0.42. In the year 2011, what is the difference between the Expenses (% of total expenses) of Euro area and Expenses (% of total expenses) of Lower middle income?
Provide a short and direct response. -8.22. In the year 2011, what is the difference between the Expenses (% of total expenses) of Euro area and Expenses (% of total expenses) of Denmark?
Ensure brevity in your answer.  -0.58. In the year 2011, what is the difference between the Expenses (% of total expenses) of High income: OECD and Expenses (% of total expenses) of Lower middle income?
Provide a succinct answer. -7.8. In the year 2011, what is the difference between the Expenses (% of total expenses) in High income: OECD and Expenses (% of total expenses) in Denmark?
Your answer should be very brief. -0.16. In the year 2011, what is the difference between the Expenses (% of total expenses) in Lower middle income and Expenses (% of total expenses) in Denmark?
Offer a terse response. 7.64. What is the ratio of the Expenses (% of total expenses) of Euro area in 2004 to that in 2005?
Your answer should be compact. 0.69. What is the ratio of the Expenses (% of total expenses) in High income: OECD in 2004 to that in 2005?
Offer a terse response. 0.99. What is the ratio of the Expenses (% of total expenses) of Lower middle income in 2004 to that in 2005?
Ensure brevity in your answer.  0.9. What is the ratio of the Expenses (% of total expenses) of Denmark in 2004 to that in 2005?
Your answer should be compact. 0.99. What is the ratio of the Expenses (% of total expenses) in Euro area in 2004 to that in 2006?
Give a very brief answer. 0.68. What is the ratio of the Expenses (% of total expenses) of High income: OECD in 2004 to that in 2006?
Ensure brevity in your answer.  0.95. What is the ratio of the Expenses (% of total expenses) of Lower middle income in 2004 to that in 2006?
Your answer should be very brief. 0.94. What is the ratio of the Expenses (% of total expenses) of Denmark in 2004 to that in 2006?
Ensure brevity in your answer.  0.92. What is the ratio of the Expenses (% of total expenses) of Euro area in 2004 to that in 2007?
Provide a succinct answer. 0.78. What is the ratio of the Expenses (% of total expenses) in Lower middle income in 2004 to that in 2007?
Offer a terse response. 0.97. What is the ratio of the Expenses (% of total expenses) in Denmark in 2004 to that in 2007?
Offer a very short reply. 0.99. What is the ratio of the Expenses (% of total expenses) in Euro area in 2004 to that in 2008?
Ensure brevity in your answer.  0.69. What is the ratio of the Expenses (% of total expenses) of High income: OECD in 2004 to that in 2008?
Provide a short and direct response. 0.99. What is the ratio of the Expenses (% of total expenses) in Lower middle income in 2004 to that in 2008?
Offer a very short reply. 0.96. What is the ratio of the Expenses (% of total expenses) in Denmark in 2004 to that in 2008?
Ensure brevity in your answer.  1.02. What is the ratio of the Expenses (% of total expenses) in Euro area in 2004 to that in 2009?
Give a very brief answer. 0.93. What is the ratio of the Expenses (% of total expenses) in High income: OECD in 2004 to that in 2009?
Your answer should be very brief. 1.01. What is the ratio of the Expenses (% of total expenses) of Lower middle income in 2004 to that in 2009?
Provide a short and direct response. 0.92. What is the ratio of the Expenses (% of total expenses) in Denmark in 2004 to that in 2009?
Provide a short and direct response. 1.05. What is the ratio of the Expenses (% of total expenses) of Euro area in 2004 to that in 2010?
Ensure brevity in your answer.  0.94. What is the ratio of the Expenses (% of total expenses) of High income: OECD in 2004 to that in 2010?
Your answer should be very brief. 1.14. What is the ratio of the Expenses (% of total expenses) of Lower middle income in 2004 to that in 2010?
Give a very brief answer. 1.02. What is the ratio of the Expenses (% of total expenses) of Denmark in 2004 to that in 2010?
Your response must be concise. 1.11. What is the ratio of the Expenses (% of total expenses) of Euro area in 2004 to that in 2011?
Your answer should be very brief. 0.91. What is the ratio of the Expenses (% of total expenses) of High income: OECD in 2004 to that in 2011?
Offer a terse response. 1.13. What is the ratio of the Expenses (% of total expenses) of Lower middle income in 2004 to that in 2011?
Ensure brevity in your answer.  0.96. What is the ratio of the Expenses (% of total expenses) in Denmark in 2004 to that in 2011?
Offer a terse response. 1.11. What is the ratio of the Expenses (% of total expenses) in High income: OECD in 2005 to that in 2006?
Offer a terse response. 0.96. What is the ratio of the Expenses (% of total expenses) in Lower middle income in 2005 to that in 2006?
Make the answer very short. 1.05. What is the ratio of the Expenses (% of total expenses) of Denmark in 2005 to that in 2006?
Offer a terse response. 0.93. What is the ratio of the Expenses (% of total expenses) of Euro area in 2005 to that in 2007?
Make the answer very short. 1.14. What is the ratio of the Expenses (% of total expenses) of High income: OECD in 2005 to that in 2007?
Give a very brief answer. 1.03. What is the ratio of the Expenses (% of total expenses) in Lower middle income in 2005 to that in 2007?
Offer a very short reply. 1.08. What is the ratio of the Expenses (% of total expenses) in Denmark in 2005 to that in 2007?
Provide a short and direct response. 1. What is the ratio of the Expenses (% of total expenses) in High income: OECD in 2005 to that in 2008?
Your response must be concise. 1. What is the ratio of the Expenses (% of total expenses) of Lower middle income in 2005 to that in 2008?
Keep it short and to the point. 1.07. What is the ratio of the Expenses (% of total expenses) in Denmark in 2005 to that in 2008?
Your response must be concise. 1.03. What is the ratio of the Expenses (% of total expenses) in Euro area in 2005 to that in 2009?
Provide a short and direct response. 1.35. What is the ratio of the Expenses (% of total expenses) of High income: OECD in 2005 to that in 2009?
Offer a terse response. 1.02. What is the ratio of the Expenses (% of total expenses) of Lower middle income in 2005 to that in 2009?
Provide a succinct answer. 1.02. What is the ratio of the Expenses (% of total expenses) of Denmark in 2005 to that in 2009?
Keep it short and to the point. 1.07. What is the ratio of the Expenses (% of total expenses) in Euro area in 2005 to that in 2010?
Your answer should be very brief. 1.37. What is the ratio of the Expenses (% of total expenses) of High income: OECD in 2005 to that in 2010?
Provide a succinct answer. 1.15. What is the ratio of the Expenses (% of total expenses) in Lower middle income in 2005 to that in 2010?
Offer a very short reply. 1.14. What is the ratio of the Expenses (% of total expenses) of Denmark in 2005 to that in 2010?
Make the answer very short. 1.13. What is the ratio of the Expenses (% of total expenses) in Euro area in 2005 to that in 2011?
Your response must be concise. 1.32. What is the ratio of the Expenses (% of total expenses) of High income: OECD in 2005 to that in 2011?
Your answer should be very brief. 1.14. What is the ratio of the Expenses (% of total expenses) of Lower middle income in 2005 to that in 2011?
Ensure brevity in your answer.  1.07. What is the ratio of the Expenses (% of total expenses) in Denmark in 2005 to that in 2011?
Your answer should be compact. 1.12. What is the ratio of the Expenses (% of total expenses) of Euro area in 2006 to that in 2007?
Provide a short and direct response. 1.15. What is the ratio of the Expenses (% of total expenses) of High income: OECD in 2006 to that in 2007?
Keep it short and to the point. 1.06. What is the ratio of the Expenses (% of total expenses) in Lower middle income in 2006 to that in 2007?
Offer a terse response. 1.03. What is the ratio of the Expenses (% of total expenses) of Denmark in 2006 to that in 2007?
Your answer should be very brief. 1.07. What is the ratio of the Expenses (% of total expenses) of Euro area in 2006 to that in 2008?
Offer a very short reply. 1. What is the ratio of the Expenses (% of total expenses) in High income: OECD in 2006 to that in 2008?
Provide a succinct answer. 1.04. What is the ratio of the Expenses (% of total expenses) in Lower middle income in 2006 to that in 2008?
Make the answer very short. 1.02. What is the ratio of the Expenses (% of total expenses) of Denmark in 2006 to that in 2008?
Offer a very short reply. 1.1. What is the ratio of the Expenses (% of total expenses) of Euro area in 2006 to that in 2009?
Give a very brief answer. 1.36. What is the ratio of the Expenses (% of total expenses) in High income: OECD in 2006 to that in 2009?
Provide a succinct answer. 1.05. What is the ratio of the Expenses (% of total expenses) of Lower middle income in 2006 to that in 2009?
Your answer should be very brief. 0.97. What is the ratio of the Expenses (% of total expenses) of Denmark in 2006 to that in 2009?
Ensure brevity in your answer.  1.14. What is the ratio of the Expenses (% of total expenses) in Euro area in 2006 to that in 2010?
Make the answer very short. 1.38. What is the ratio of the Expenses (% of total expenses) of High income: OECD in 2006 to that in 2010?
Your response must be concise. 1.19. What is the ratio of the Expenses (% of total expenses) in Lower middle income in 2006 to that in 2010?
Provide a short and direct response. 1.08. What is the ratio of the Expenses (% of total expenses) of Denmark in 2006 to that in 2010?
Keep it short and to the point. 1.21. What is the ratio of the Expenses (% of total expenses) in Euro area in 2006 to that in 2011?
Offer a terse response. 1.33. What is the ratio of the Expenses (% of total expenses) of High income: OECD in 2006 to that in 2011?
Ensure brevity in your answer.  1.18. What is the ratio of the Expenses (% of total expenses) of Lower middle income in 2006 to that in 2011?
Keep it short and to the point. 1.01. What is the ratio of the Expenses (% of total expenses) in Euro area in 2007 to that in 2008?
Provide a succinct answer. 0.87. What is the ratio of the Expenses (% of total expenses) of High income: OECD in 2007 to that in 2008?
Provide a short and direct response. 0.98. What is the ratio of the Expenses (% of total expenses) of Denmark in 2007 to that in 2008?
Offer a very short reply. 1.03. What is the ratio of the Expenses (% of total expenses) of Euro area in 2007 to that in 2009?
Your response must be concise. 1.19. What is the ratio of the Expenses (% of total expenses) in Lower middle income in 2007 to that in 2009?
Ensure brevity in your answer.  0.95. What is the ratio of the Expenses (% of total expenses) of Denmark in 2007 to that in 2009?
Keep it short and to the point. 1.07. What is the ratio of the Expenses (% of total expenses) of Euro area in 2007 to that in 2010?
Keep it short and to the point. 1.2. What is the ratio of the Expenses (% of total expenses) of High income: OECD in 2007 to that in 2010?
Provide a succinct answer. 1.12. What is the ratio of the Expenses (% of total expenses) in Lower middle income in 2007 to that in 2010?
Ensure brevity in your answer.  1.06. What is the ratio of the Expenses (% of total expenses) of Denmark in 2007 to that in 2010?
Your response must be concise. 1.13. What is the ratio of the Expenses (% of total expenses) in Euro area in 2007 to that in 2011?
Your answer should be very brief. 1.16. What is the ratio of the Expenses (% of total expenses) of High income: OECD in 2007 to that in 2011?
Provide a short and direct response. 1.11. What is the ratio of the Expenses (% of total expenses) of Lower middle income in 2007 to that in 2011?
Give a very brief answer. 0.99. What is the ratio of the Expenses (% of total expenses) in Denmark in 2007 to that in 2011?
Your answer should be very brief. 1.12. What is the ratio of the Expenses (% of total expenses) in Euro area in 2008 to that in 2009?
Make the answer very short. 1.36. What is the ratio of the Expenses (% of total expenses) in High income: OECD in 2008 to that in 2009?
Offer a terse response. 1.02. What is the ratio of the Expenses (% of total expenses) of Lower middle income in 2008 to that in 2009?
Offer a very short reply. 0.96. What is the ratio of the Expenses (% of total expenses) in Denmark in 2008 to that in 2009?
Provide a succinct answer. 1.03. What is the ratio of the Expenses (% of total expenses) in Euro area in 2008 to that in 2010?
Offer a very short reply. 1.38. What is the ratio of the Expenses (% of total expenses) in High income: OECD in 2008 to that in 2010?
Provide a short and direct response. 1.15. What is the ratio of the Expenses (% of total expenses) in Lower middle income in 2008 to that in 2010?
Your answer should be very brief. 1.06. What is the ratio of the Expenses (% of total expenses) in Denmark in 2008 to that in 2010?
Keep it short and to the point. 1.1. What is the ratio of the Expenses (% of total expenses) of Euro area in 2008 to that in 2011?
Offer a terse response. 1.33. What is the ratio of the Expenses (% of total expenses) in High income: OECD in 2008 to that in 2011?
Your answer should be very brief. 1.14. What is the ratio of the Expenses (% of total expenses) in Denmark in 2008 to that in 2011?
Keep it short and to the point. 1.09. What is the ratio of the Expenses (% of total expenses) of Euro area in 2009 to that in 2010?
Offer a very short reply. 1.01. What is the ratio of the Expenses (% of total expenses) of High income: OECD in 2009 to that in 2010?
Offer a very short reply. 1.13. What is the ratio of the Expenses (% of total expenses) in Lower middle income in 2009 to that in 2010?
Offer a terse response. 1.11. What is the ratio of the Expenses (% of total expenses) in Denmark in 2009 to that in 2010?
Give a very brief answer. 1.06. What is the ratio of the Expenses (% of total expenses) in Euro area in 2009 to that in 2011?
Your answer should be compact. 0.98. What is the ratio of the Expenses (% of total expenses) of High income: OECD in 2009 to that in 2011?
Offer a very short reply. 1.12. What is the ratio of the Expenses (% of total expenses) in Lower middle income in 2009 to that in 2011?
Offer a very short reply. 1.04. What is the ratio of the Expenses (% of total expenses) of Denmark in 2009 to that in 2011?
Your answer should be compact. 1.05. What is the ratio of the Expenses (% of total expenses) in Lower middle income in 2010 to that in 2011?
Your answer should be very brief. 0.94. What is the ratio of the Expenses (% of total expenses) in Denmark in 2010 to that in 2011?
Your answer should be compact. 0.99. What is the difference between the highest and the second highest Expenses (% of total expenses) in Euro area?
Keep it short and to the point. 0.04. What is the difference between the highest and the second highest Expenses (% of total expenses) of High income: OECD?
Make the answer very short. 0.34. What is the difference between the highest and the second highest Expenses (% of total expenses) in Lower middle income?
Your response must be concise. 0.39. What is the difference between the highest and the second highest Expenses (% of total expenses) of Denmark?
Provide a succinct answer. 0.65. What is the difference between the highest and the lowest Expenses (% of total expenses) of Euro area?
Make the answer very short. 3.21. What is the difference between the highest and the lowest Expenses (% of total expenses) in High income: OECD?
Give a very brief answer. 1.53. What is the difference between the highest and the lowest Expenses (% of total expenses) in Lower middle income?
Provide a short and direct response. 2.06. What is the difference between the highest and the lowest Expenses (% of total expenses) of Denmark?
Your answer should be compact. 1.7. 